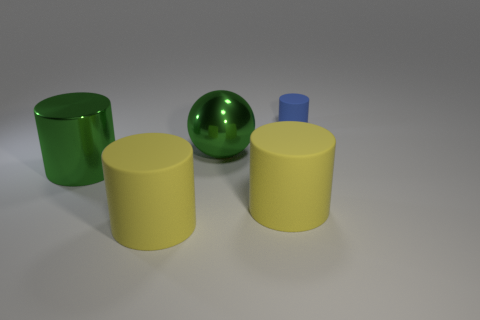Is there any other thing that has the same size as the blue matte cylinder?
Offer a very short reply. No. There is a big object that is the same color as the sphere; what is it made of?
Your answer should be very brief. Metal. Does the big shiny sphere have the same color as the big metal cylinder?
Provide a short and direct response. Yes. Does the large metal object that is in front of the green sphere have the same color as the sphere?
Keep it short and to the point. Yes. Is the color of the ball the same as the metal thing in front of the metal ball?
Provide a succinct answer. Yes. There is a thing that is the same color as the metallic cylinder; what is its size?
Your response must be concise. Large. There is a blue object; is it the same shape as the big matte object that is to the right of the big green sphere?
Ensure brevity in your answer.  Yes. How many objects are the same size as the green sphere?
Your response must be concise. 3. There is a blue rubber cylinder that is behind the big green object behind the big green cylinder; how many cylinders are in front of it?
Your answer should be compact. 3. Are there an equal number of big balls in front of the large shiny cylinder and big cylinders that are in front of the small cylinder?
Provide a succinct answer. No. 